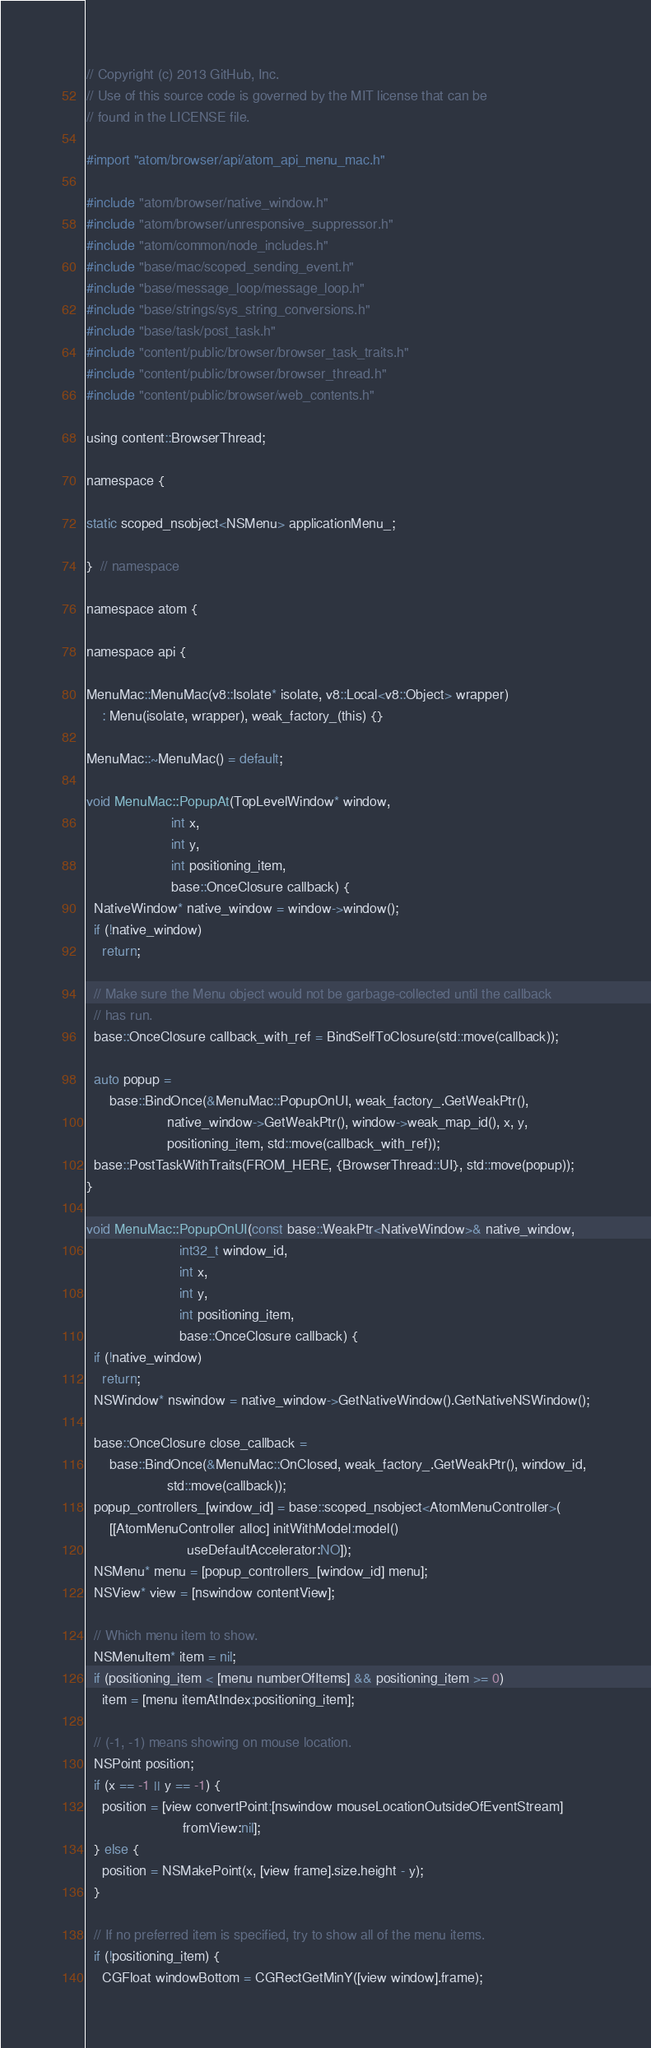<code> <loc_0><loc_0><loc_500><loc_500><_ObjectiveC_>// Copyright (c) 2013 GitHub, Inc.
// Use of this source code is governed by the MIT license that can be
// found in the LICENSE file.

#import "atom/browser/api/atom_api_menu_mac.h"

#include "atom/browser/native_window.h"
#include "atom/browser/unresponsive_suppressor.h"
#include "atom/common/node_includes.h"
#include "base/mac/scoped_sending_event.h"
#include "base/message_loop/message_loop.h"
#include "base/strings/sys_string_conversions.h"
#include "base/task/post_task.h"
#include "content/public/browser/browser_task_traits.h"
#include "content/public/browser/browser_thread.h"
#include "content/public/browser/web_contents.h"

using content::BrowserThread;

namespace {

static scoped_nsobject<NSMenu> applicationMenu_;

}  // namespace

namespace atom {

namespace api {

MenuMac::MenuMac(v8::Isolate* isolate, v8::Local<v8::Object> wrapper)
    : Menu(isolate, wrapper), weak_factory_(this) {}

MenuMac::~MenuMac() = default;

void MenuMac::PopupAt(TopLevelWindow* window,
                      int x,
                      int y,
                      int positioning_item,
                      base::OnceClosure callback) {
  NativeWindow* native_window = window->window();
  if (!native_window)
    return;

  // Make sure the Menu object would not be garbage-collected until the callback
  // has run.
  base::OnceClosure callback_with_ref = BindSelfToClosure(std::move(callback));

  auto popup =
      base::BindOnce(&MenuMac::PopupOnUI, weak_factory_.GetWeakPtr(),
                     native_window->GetWeakPtr(), window->weak_map_id(), x, y,
                     positioning_item, std::move(callback_with_ref));
  base::PostTaskWithTraits(FROM_HERE, {BrowserThread::UI}, std::move(popup));
}

void MenuMac::PopupOnUI(const base::WeakPtr<NativeWindow>& native_window,
                        int32_t window_id,
                        int x,
                        int y,
                        int positioning_item,
                        base::OnceClosure callback) {
  if (!native_window)
    return;
  NSWindow* nswindow = native_window->GetNativeWindow().GetNativeNSWindow();

  base::OnceClosure close_callback =
      base::BindOnce(&MenuMac::OnClosed, weak_factory_.GetWeakPtr(), window_id,
                     std::move(callback));
  popup_controllers_[window_id] = base::scoped_nsobject<AtomMenuController>(
      [[AtomMenuController alloc] initWithModel:model()
                          useDefaultAccelerator:NO]);
  NSMenu* menu = [popup_controllers_[window_id] menu];
  NSView* view = [nswindow contentView];

  // Which menu item to show.
  NSMenuItem* item = nil;
  if (positioning_item < [menu numberOfItems] && positioning_item >= 0)
    item = [menu itemAtIndex:positioning_item];

  // (-1, -1) means showing on mouse location.
  NSPoint position;
  if (x == -1 || y == -1) {
    position = [view convertPoint:[nswindow mouseLocationOutsideOfEventStream]
                         fromView:nil];
  } else {
    position = NSMakePoint(x, [view frame].size.height - y);
  }

  // If no preferred item is specified, try to show all of the menu items.
  if (!positioning_item) {
    CGFloat windowBottom = CGRectGetMinY([view window].frame);</code> 